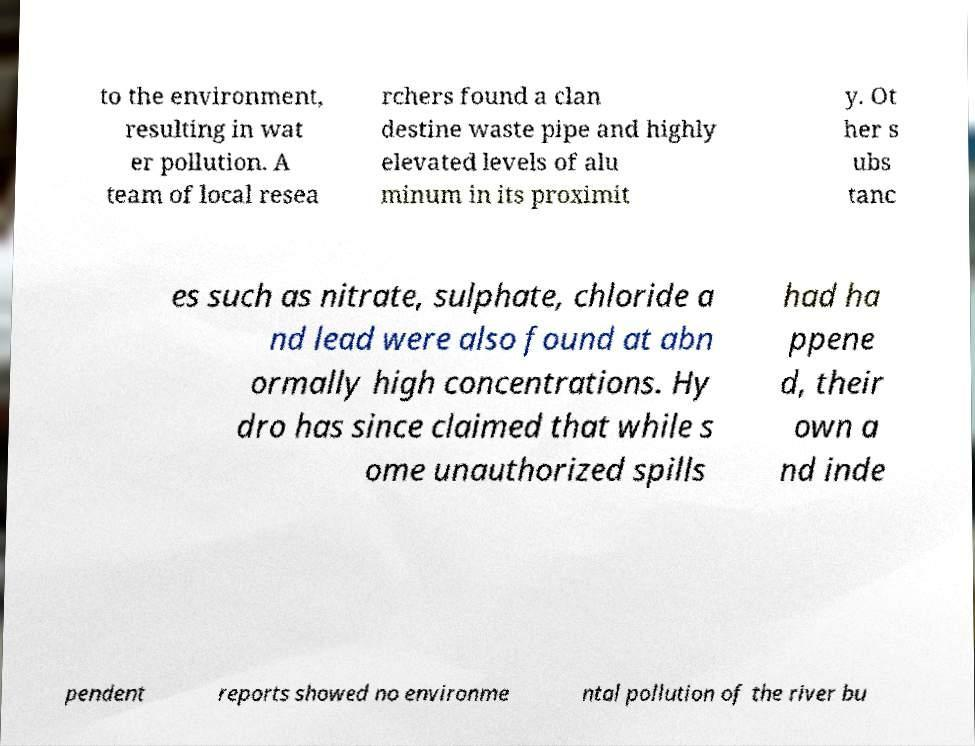What messages or text are displayed in this image? I need them in a readable, typed format. to the environment, resulting in wat er pollution. A team of local resea rchers found a clan destine waste pipe and highly elevated levels of alu minum in its proximit y. Ot her s ubs tanc es such as nitrate, sulphate, chloride a nd lead were also found at abn ormally high concentrations. Hy dro has since claimed that while s ome unauthorized spills had ha ppene d, their own a nd inde pendent reports showed no environme ntal pollution of the river bu 